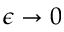<formula> <loc_0><loc_0><loc_500><loc_500>\epsilon \rightarrow 0</formula> 